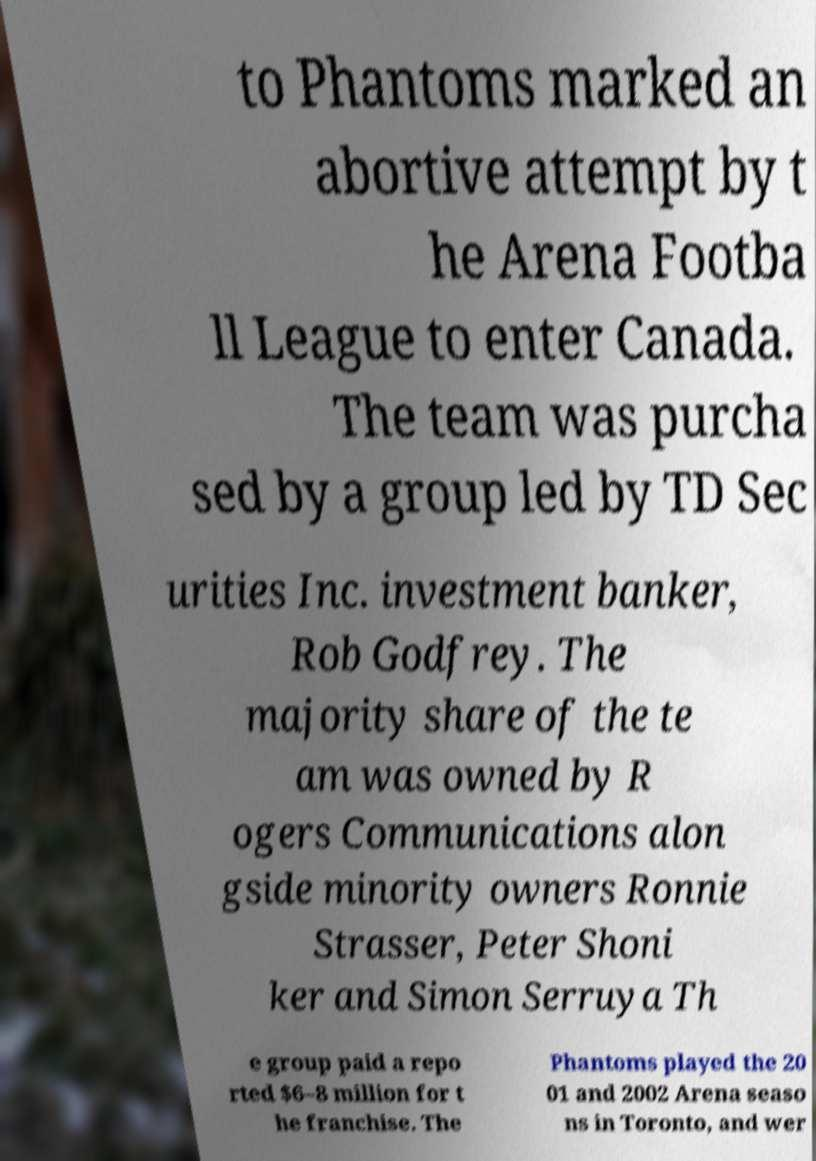There's text embedded in this image that I need extracted. Can you transcribe it verbatim? to Phantoms marked an abortive attempt by t he Arena Footba ll League to enter Canada. The team was purcha sed by a group led by TD Sec urities Inc. investment banker, Rob Godfrey. The majority share of the te am was owned by R ogers Communications alon gside minority owners Ronnie Strasser, Peter Shoni ker and Simon Serruya Th e group paid a repo rted $6–8 million for t he franchise. The Phantoms played the 20 01 and 2002 Arena seaso ns in Toronto, and wer 